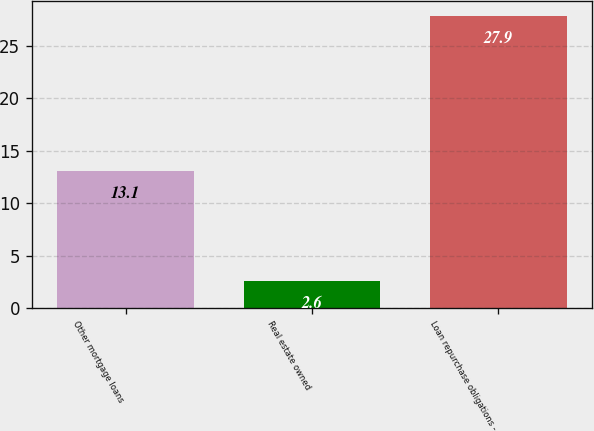Convert chart to OTSL. <chart><loc_0><loc_0><loc_500><loc_500><bar_chart><fcel>Other mortgage loans<fcel>Real estate owned<fcel>Loan repurchase obligations -<nl><fcel>13.1<fcel>2.6<fcel>27.9<nl></chart> 